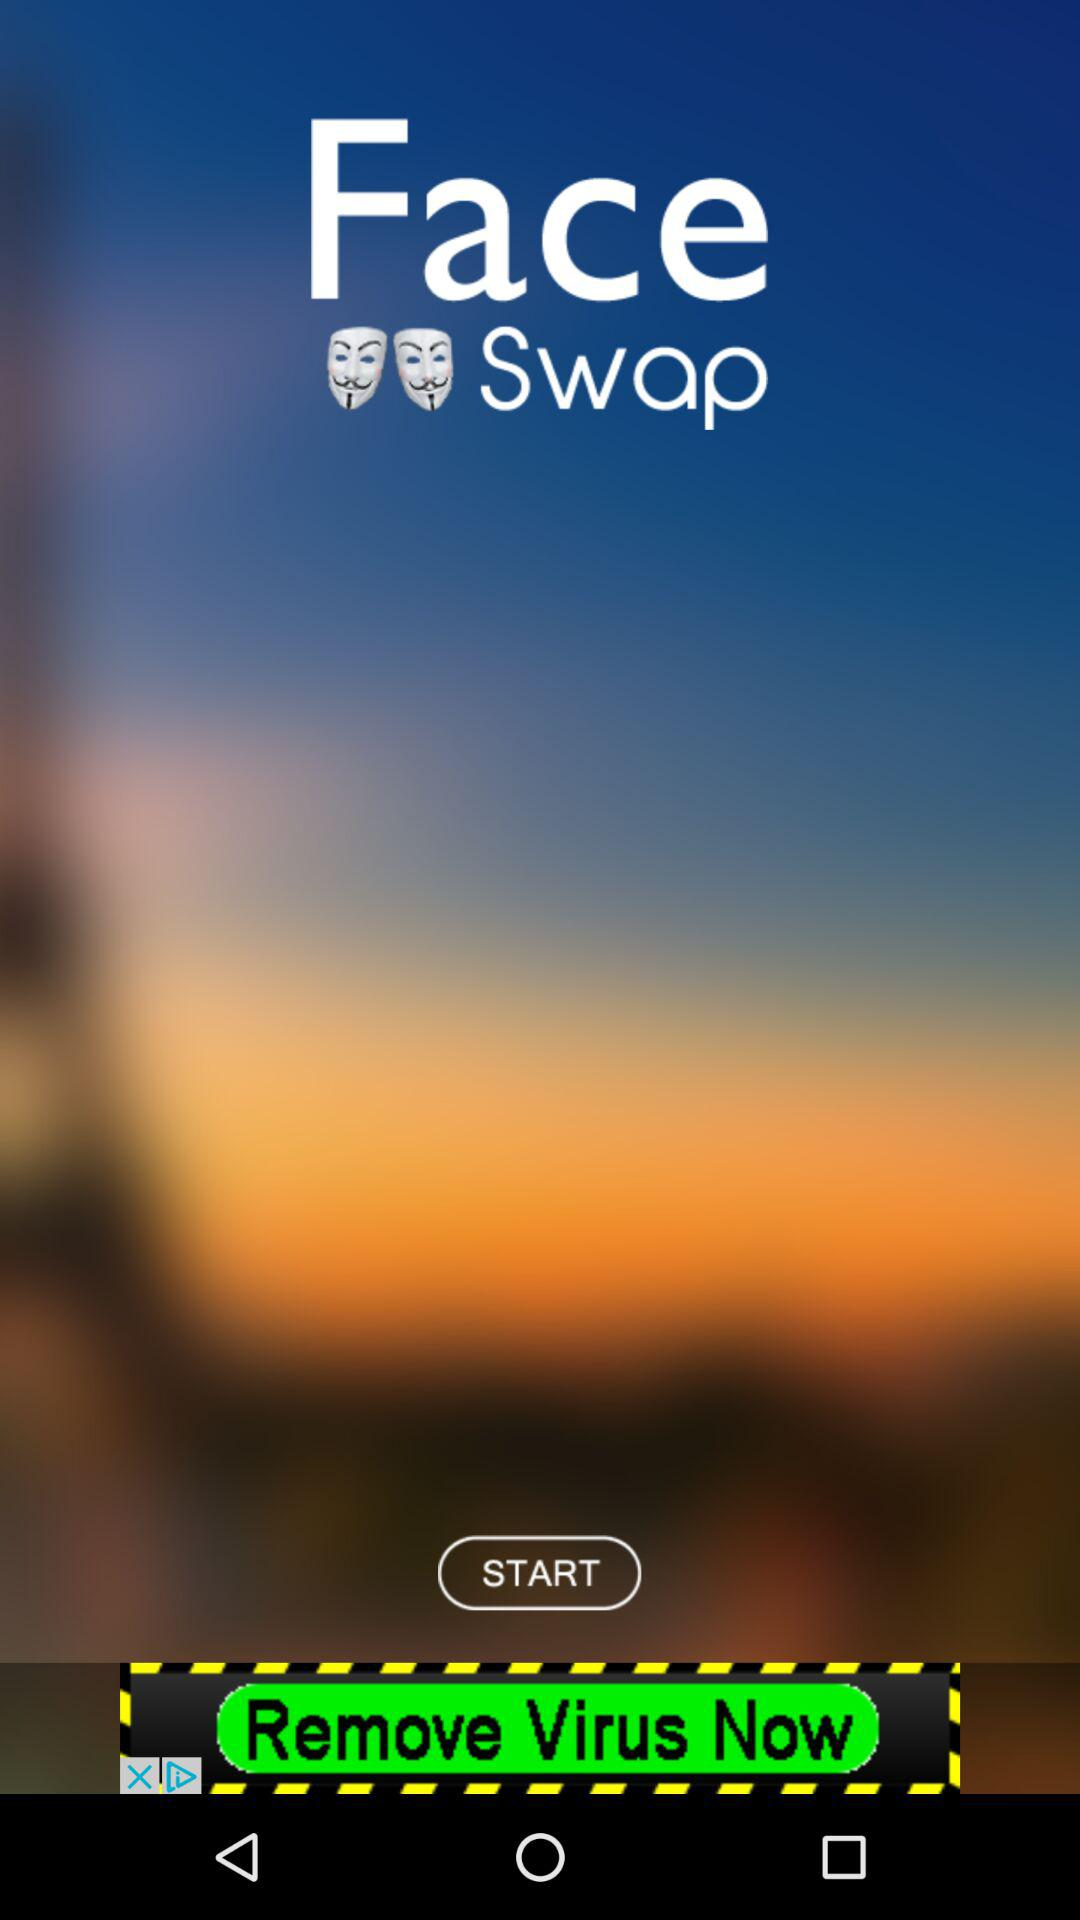How many masks are there in the app?
Answer the question using a single word or phrase. 2 